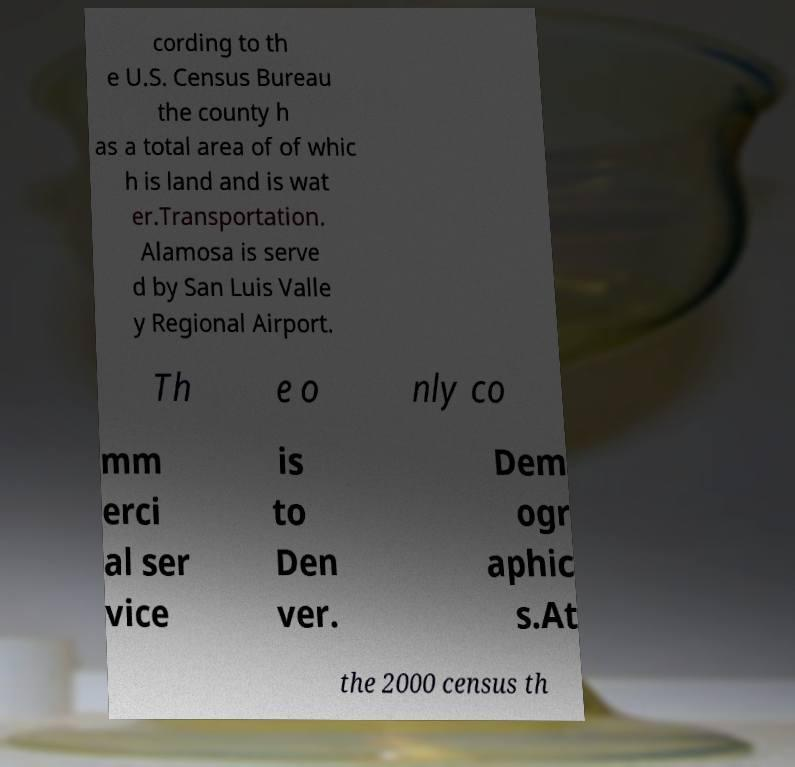Could you extract and type out the text from this image? cording to th e U.S. Census Bureau the county h as a total area of of whic h is land and is wat er.Transportation. Alamosa is serve d by San Luis Valle y Regional Airport. Th e o nly co mm erci al ser vice is to Den ver. Dem ogr aphic s.At the 2000 census th 